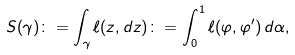<formula> <loc_0><loc_0><loc_500><loc_500>S ( \gamma ) \colon = \int _ { \gamma } \ell ( z , d z ) \colon = \int _ { 0 } ^ { 1 } \ell ( \varphi , \varphi ^ { \prime } ) \, d \alpha ,</formula> 